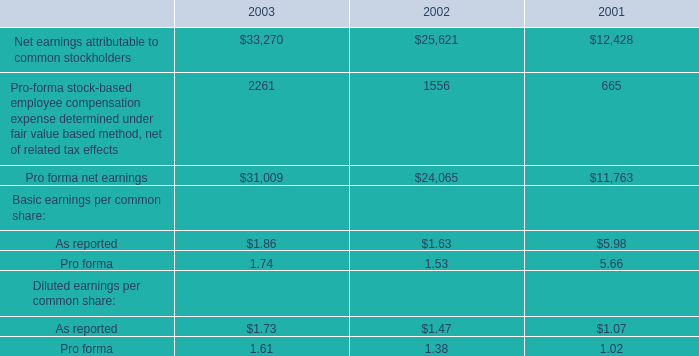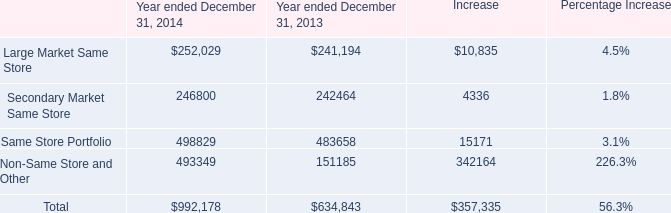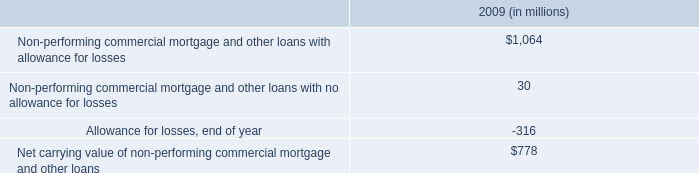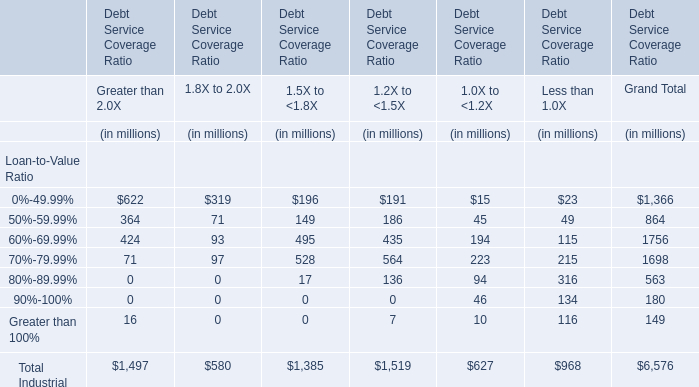what was the net income attributable to noncontrolling interests net income attributable to noncontrolling interests for the year ended december 31 , 2014 in million 
Computations: (18.5 - 10.2)
Answer: 8.3. 